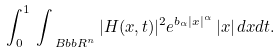<formula> <loc_0><loc_0><loc_500><loc_500>\int _ { 0 } ^ { 1 } \, \int _ { \ B b b R ^ { n } } | H ( x , t ) | ^ { 2 } e ^ { b _ { \alpha } | x | ^ { \alpha } } \, | x | \, d x d t .</formula> 